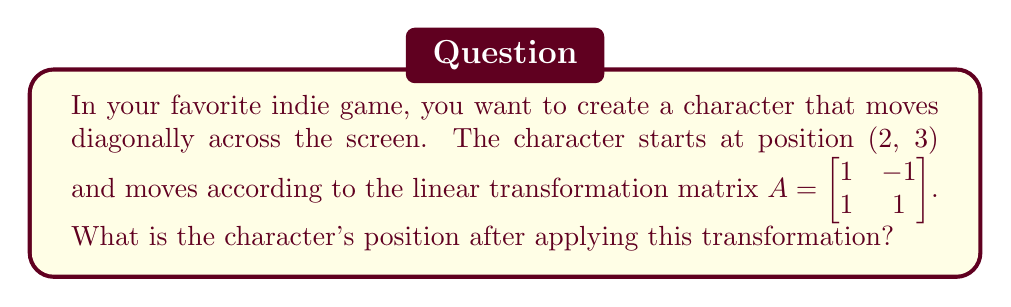Could you help me with this problem? To find the character's new position after applying the linear transformation, we need to multiply the transformation matrix by the initial position vector. Let's break this down step-by-step:

1. Initial position vector: $\vec{v} = \begin{bmatrix} 2 \\ 3 \end{bmatrix}$

2. Transformation matrix: $A = \begin{bmatrix} 1 & -1 \\ 1 & 1 \end{bmatrix}$

3. To apply the transformation, we multiply $A$ by $\vec{v}$:

   $$A\vec{v} = \begin{bmatrix} 1 & -1 \\ 1 & 1 \end{bmatrix} \begin{bmatrix} 2 \\ 3 \end{bmatrix}$$

4. Perform the matrix multiplication:
   
   $$\begin{bmatrix} 1(2) + (-1)(3) \\ 1(2) + 1(3) \end{bmatrix}$$

5. Calculate each element:
   
   $$\begin{bmatrix} 2 - 3 \\ 2 + 3 \end{bmatrix} = \begin{bmatrix} -1 \\ 5 \end{bmatrix}$$

Therefore, after applying the linear transformation, the character's new position is (-1, 5).
Answer: (-1, 5) 